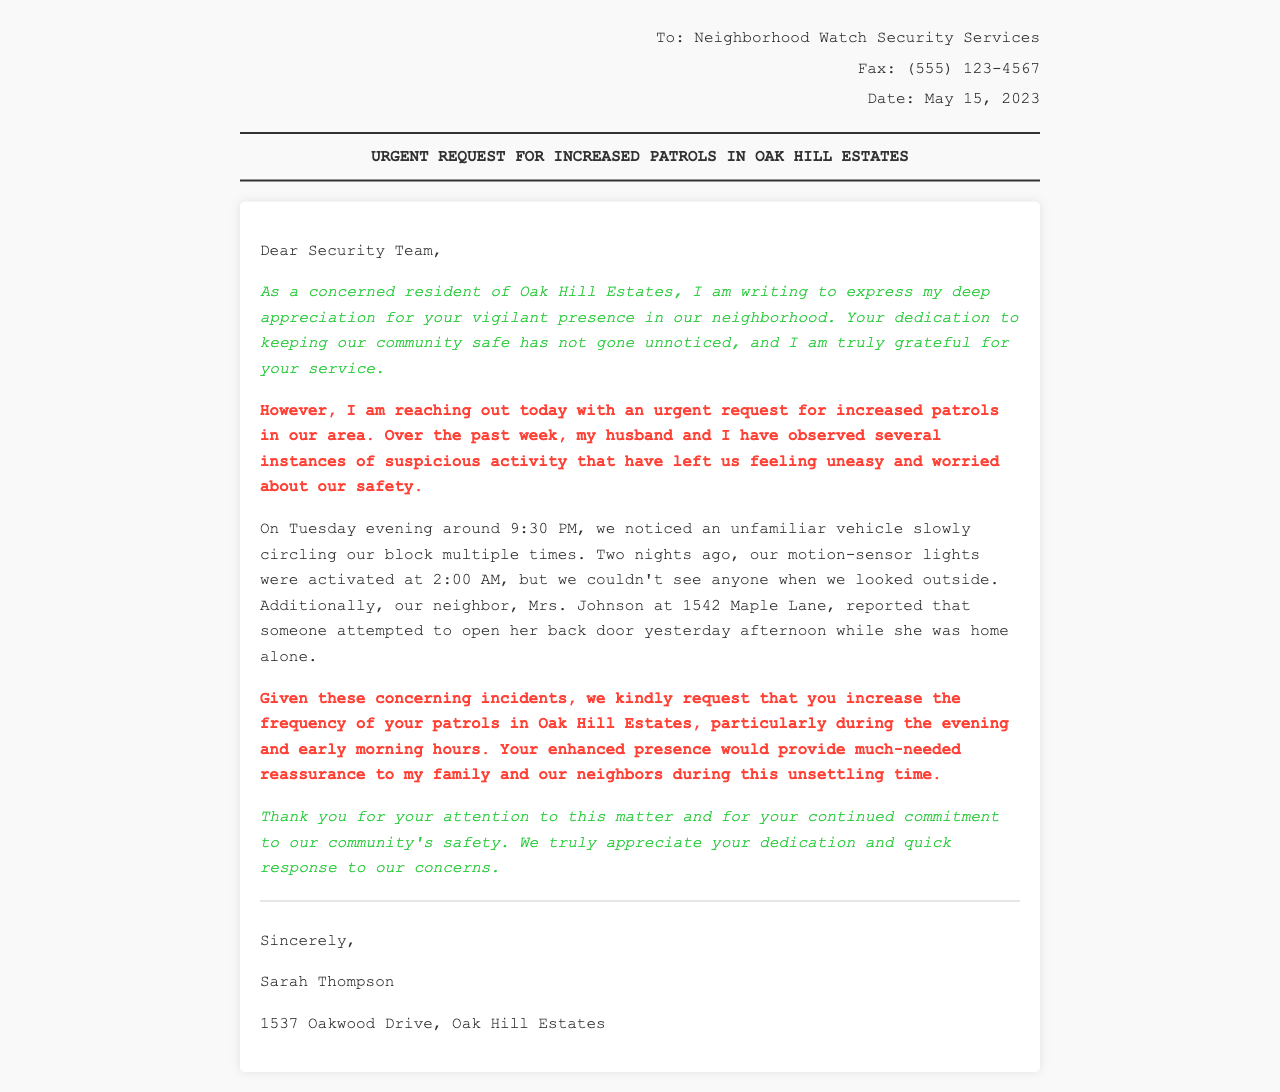What is the date of the fax? The date of the fax is stated at the beginning of the document, which shows "May 15, 2023."
Answer: May 15, 2023 Who is the sender of the fax? The sender's name is listed at the end of the document, identifying "Sarah Thompson."
Answer: Sarah Thompson What issue prompted the request for increased patrols? The document mentions suspicious activity observed by the sender, which includes an unfamiliar vehicle and attempted break-ins.
Answer: Suspicious activity What was observed on Tuesday evening? The document details an event where an unfamiliar vehicle circled the block multiple times on Tuesday evening.
Answer: Unfamiliar vehicle What specific time were the motion-sensor lights activated? The letter notes that the motion-sensor lights were activated at 2:00 AM, indicating a noteworthy event.
Answer: 2:00 AM What is the address of the sender? The sender provides their address in the signature section of the document, which is "1537 Oakwood Drive, Oak Hill Estates."
Answer: 1537 Oakwood Drive, Oak Hill Estates What request is made by the sender? The sender requests that the security services increase the frequency of their patrols in the neighborhood.
Answer: Increase patrols What neighborhood is mentioned in the document? The document specifies "Oak Hill Estates" as the neighborhood where the events and request are placed.
Answer: Oak Hill Estates What type of document is this? This document is a fax, as indicated in the header and overall communication structure.
Answer: Fax 